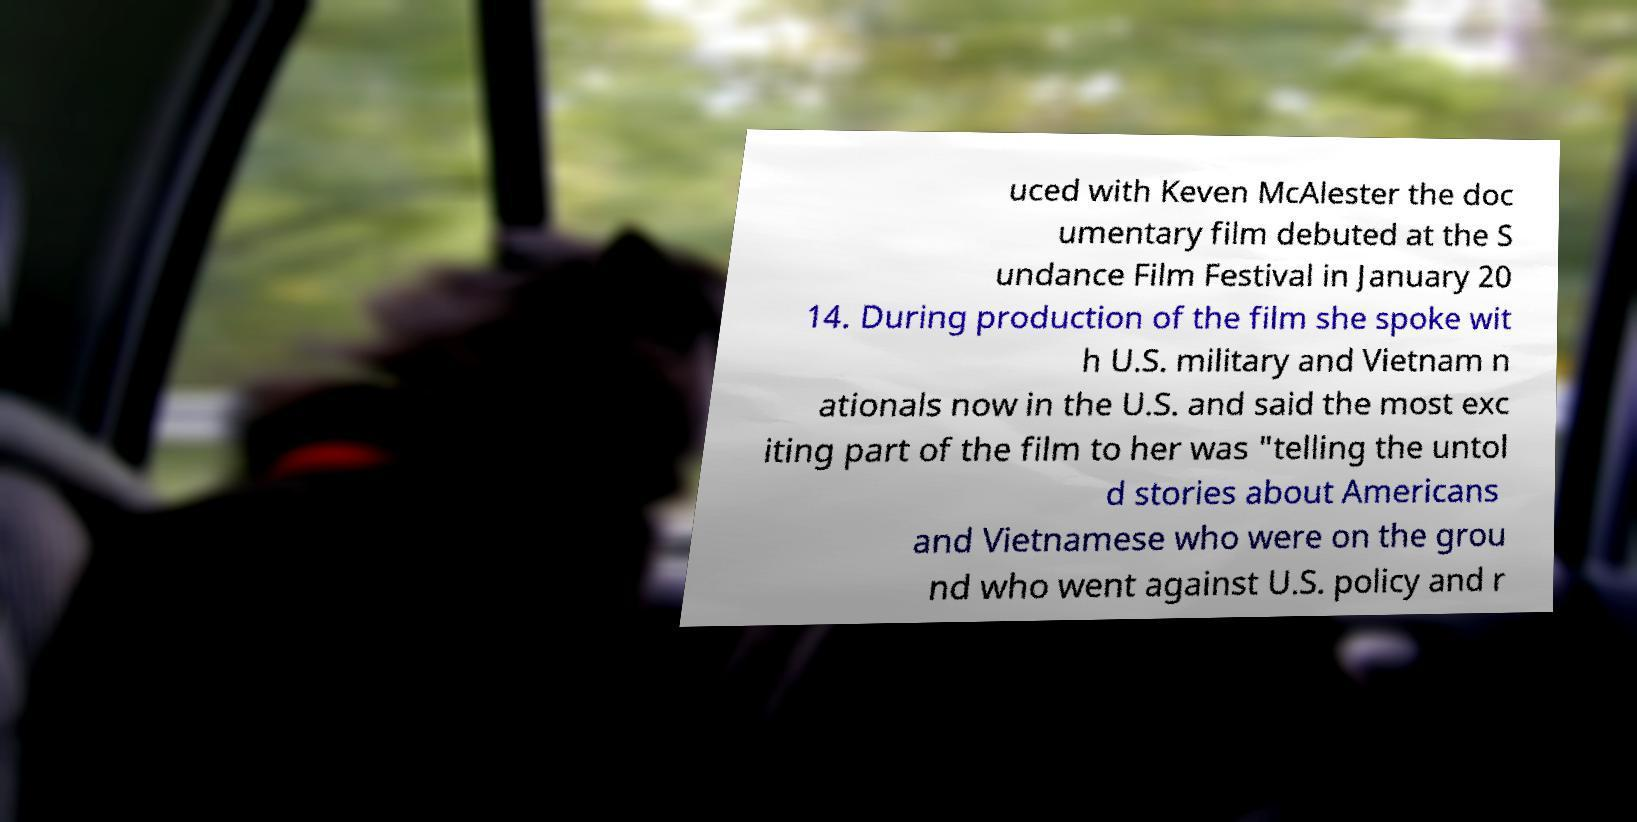Could you assist in decoding the text presented in this image and type it out clearly? uced with Keven McAlester the doc umentary film debuted at the S undance Film Festival in January 20 14. During production of the film she spoke wit h U.S. military and Vietnam n ationals now in the U.S. and said the most exc iting part of the film to her was "telling the untol d stories about Americans and Vietnamese who were on the grou nd who went against U.S. policy and r 